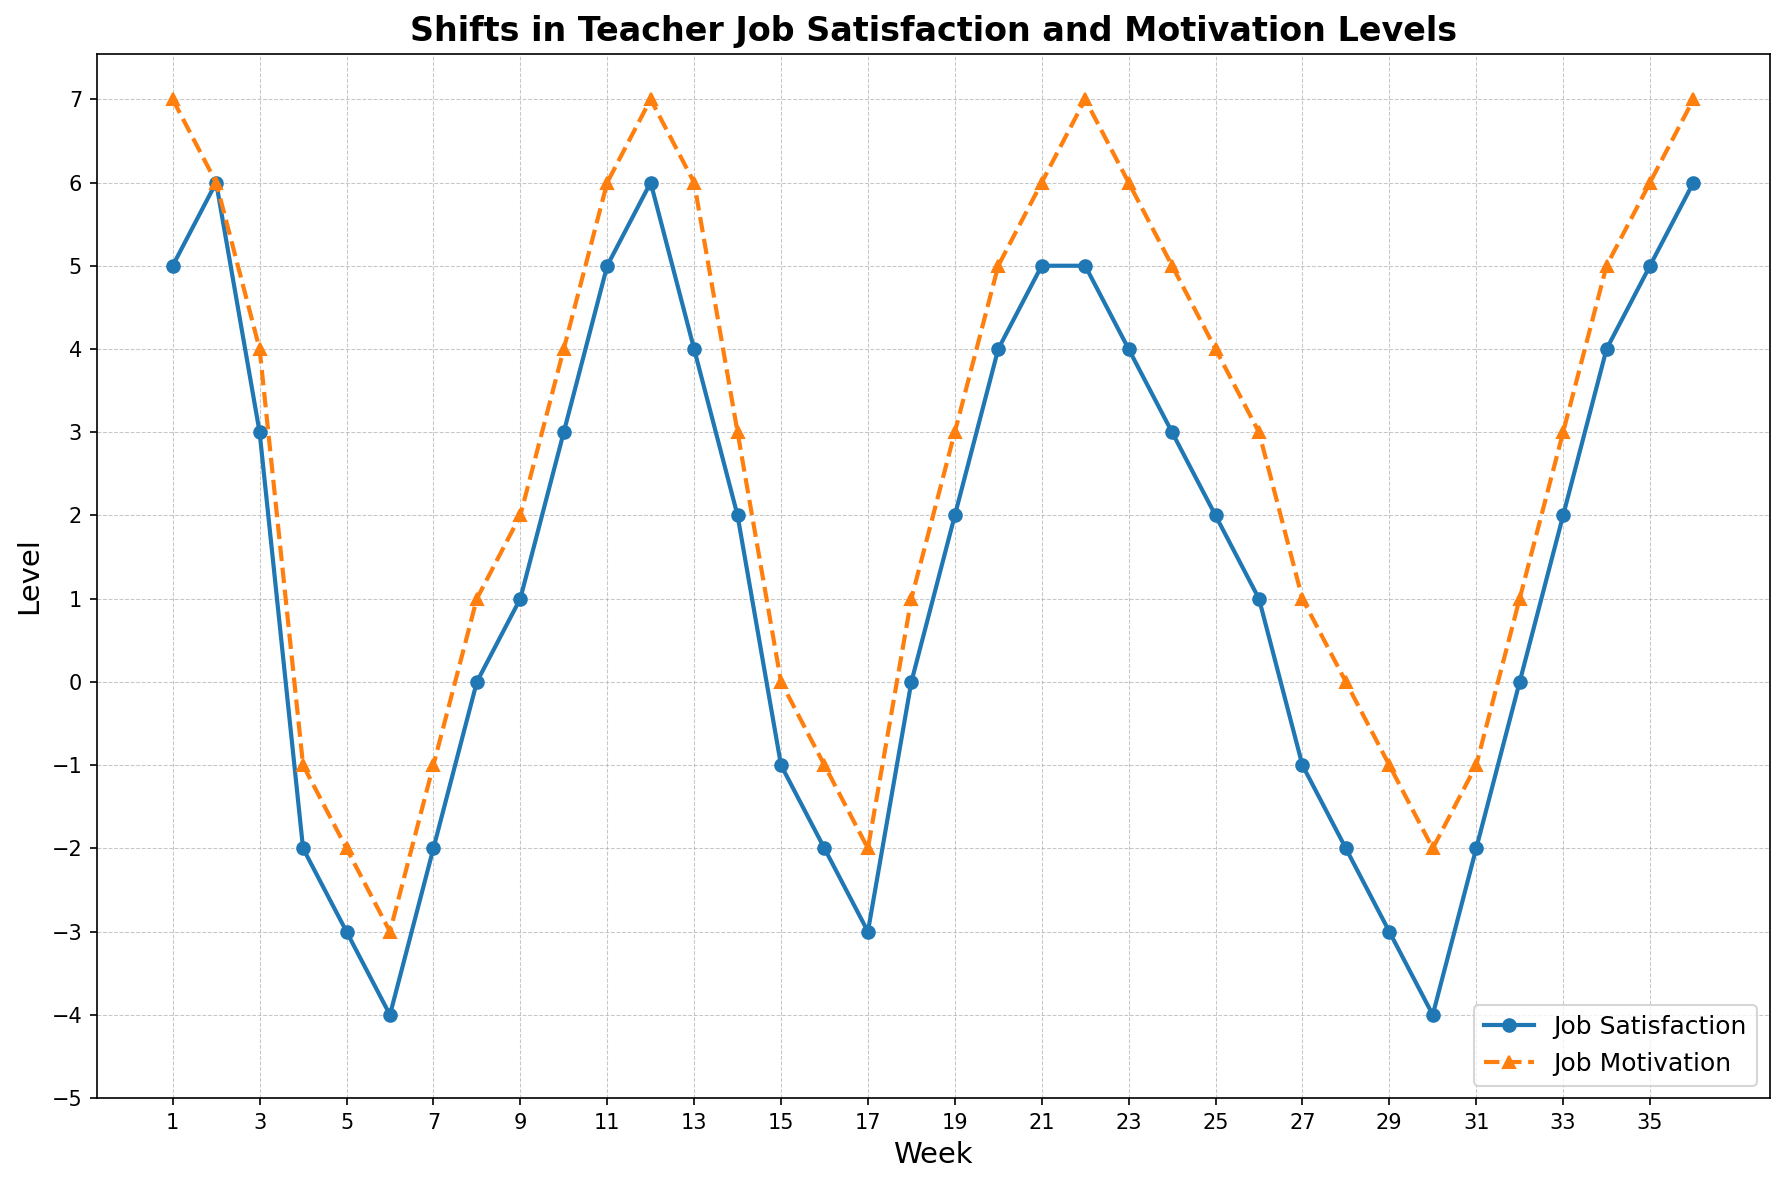What is the job satisfaction level at its lowest point? To find the lowest job satisfaction level, look for the lowest point in the blue line on the chart. The lowest point occurs in week 30 where the job satisfaction level is -4.
Answer: -4 During which week does job motivation reach its minimum value? To find the minimum value of job motivation, look for the lowest point on the orange line. This occurs in week 30 where the job motivation level is -2.
Answer: Week 30 Compare the job satisfaction levels at week 4 and week 16. Which is lower, and by how much? To compare the levels, check the blue line at weeks 4 and 16. At week 4, job satisfaction is -2 and at week 16, it is -2. Since they are equal, the difference is 0.
Answer: Equal, 0 difference Between which weeks does the job satisfaction level first drop to a negative value? Observe the blue line and notice at which point it first goes below the horizontal axis (zero level). This occurs between weeks 3 and 4 where job satisfaction drops from 3 to -2.
Answer: Week 3 to Week 4 Calculate the average job motivation level for weeks 12, 13, and 14. Sum the job motivation levels for weeks 12 (7), 13 (6), and 14 (3). The total is 7 + 6 + 3 = 16. Then, divide by 3 to get the average: 16/3 ≈ 5.33.
Answer: 5.33 How many weeks have a job satisfaction level of 0 or higher? Count the weeks where the blue line is at or above the horizontal axis. This occurs in weeks 1-3, 8-12, 18-20, 22-26, 32-36. Summing these gives a total of 23 weeks.
Answer: 23 weeks What is the trend of the job satisfaction level from week 25 to week 30? Observe the blue line from weeks 25 to 30. It starts at week 25 with a value of 2, drops to -1 in week 27, and further down to -4 by week 30. The trend is downward.
Answer: Downward Which week shows an equal level for both job satisfaction and job motivation? Look for a week where both lines intersect or have the same value. This happens at week 27 where both job satisfaction and job motivation levels are -1.
Answer: Week 27 What are the job satisfaction and motivation levels in week 33? Refer to week 33 on the chart and read the values from the blue and orange lines. Job satisfaction is 2 and job motivation is 3.
Answer: Job Satisfaction: 2, Job Motivation: 3 Between which weeks are job satisfaction and job motivation consistently increasing? Identify a period where both lines show a continuous upward trend. From weeks 31 to 36, both job satisfaction and motivation are increasing consistently.
Answer: Week 31 to Week 36 